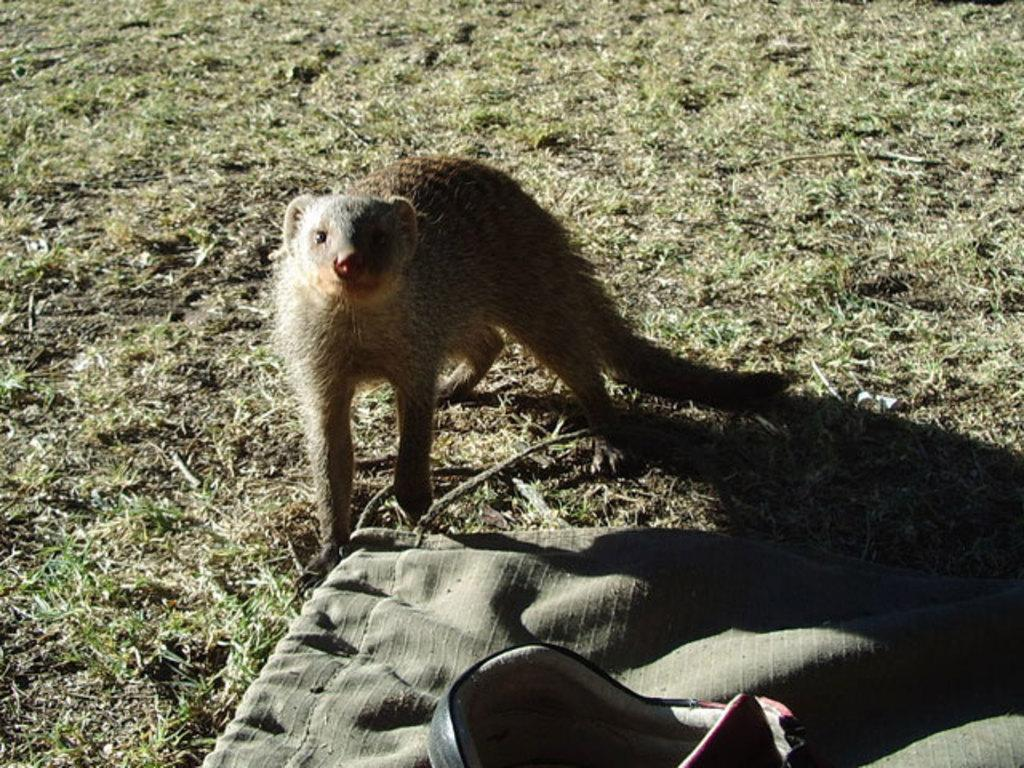What type of animal is in the picture? There is a ferret animal in the picture. What is the ferret doing in the picture? The ferret is standing on the ground. What else can be seen in the picture besides the ferret? There is a cloth and a baby trolley visible in the picture. How many mice are playing with the ferret in the picture? There are no mice present in the picture; it only features a ferret animal. What are the girls doing in the picture? There are no girls present in the picture; it only features a ferret animal, a cloth, and a baby trolley. 